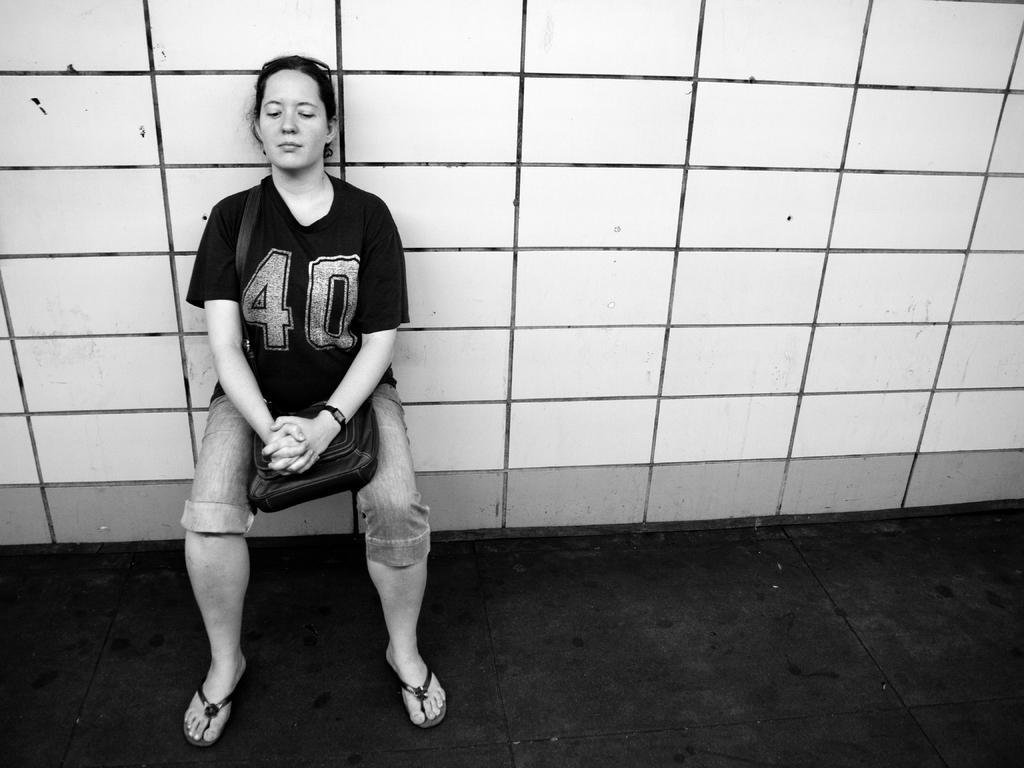Please provide a concise description of this image. In this image there is a woman performing wall chair exercise, the woman is wearing a bag. 